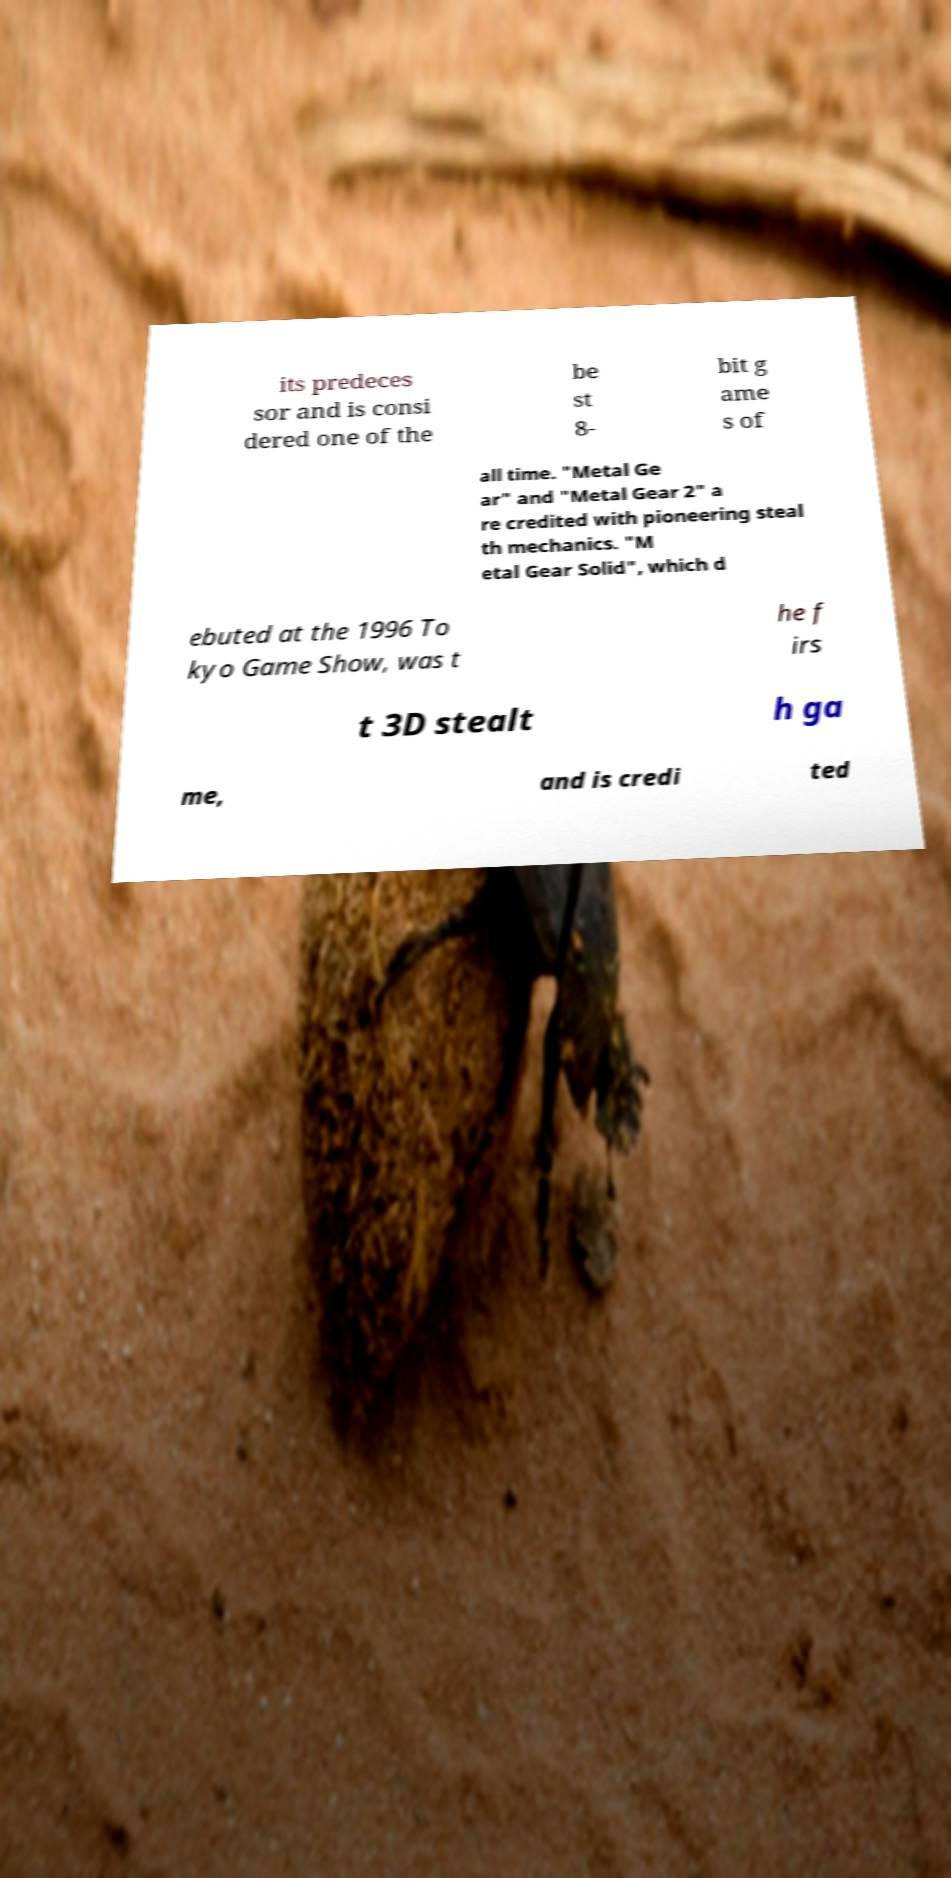Please identify and transcribe the text found in this image. its predeces sor and is consi dered one of the be st 8- bit g ame s of all time. "Metal Ge ar" and "Metal Gear 2" a re credited with pioneering steal th mechanics. "M etal Gear Solid", which d ebuted at the 1996 To kyo Game Show, was t he f irs t 3D stealt h ga me, and is credi ted 